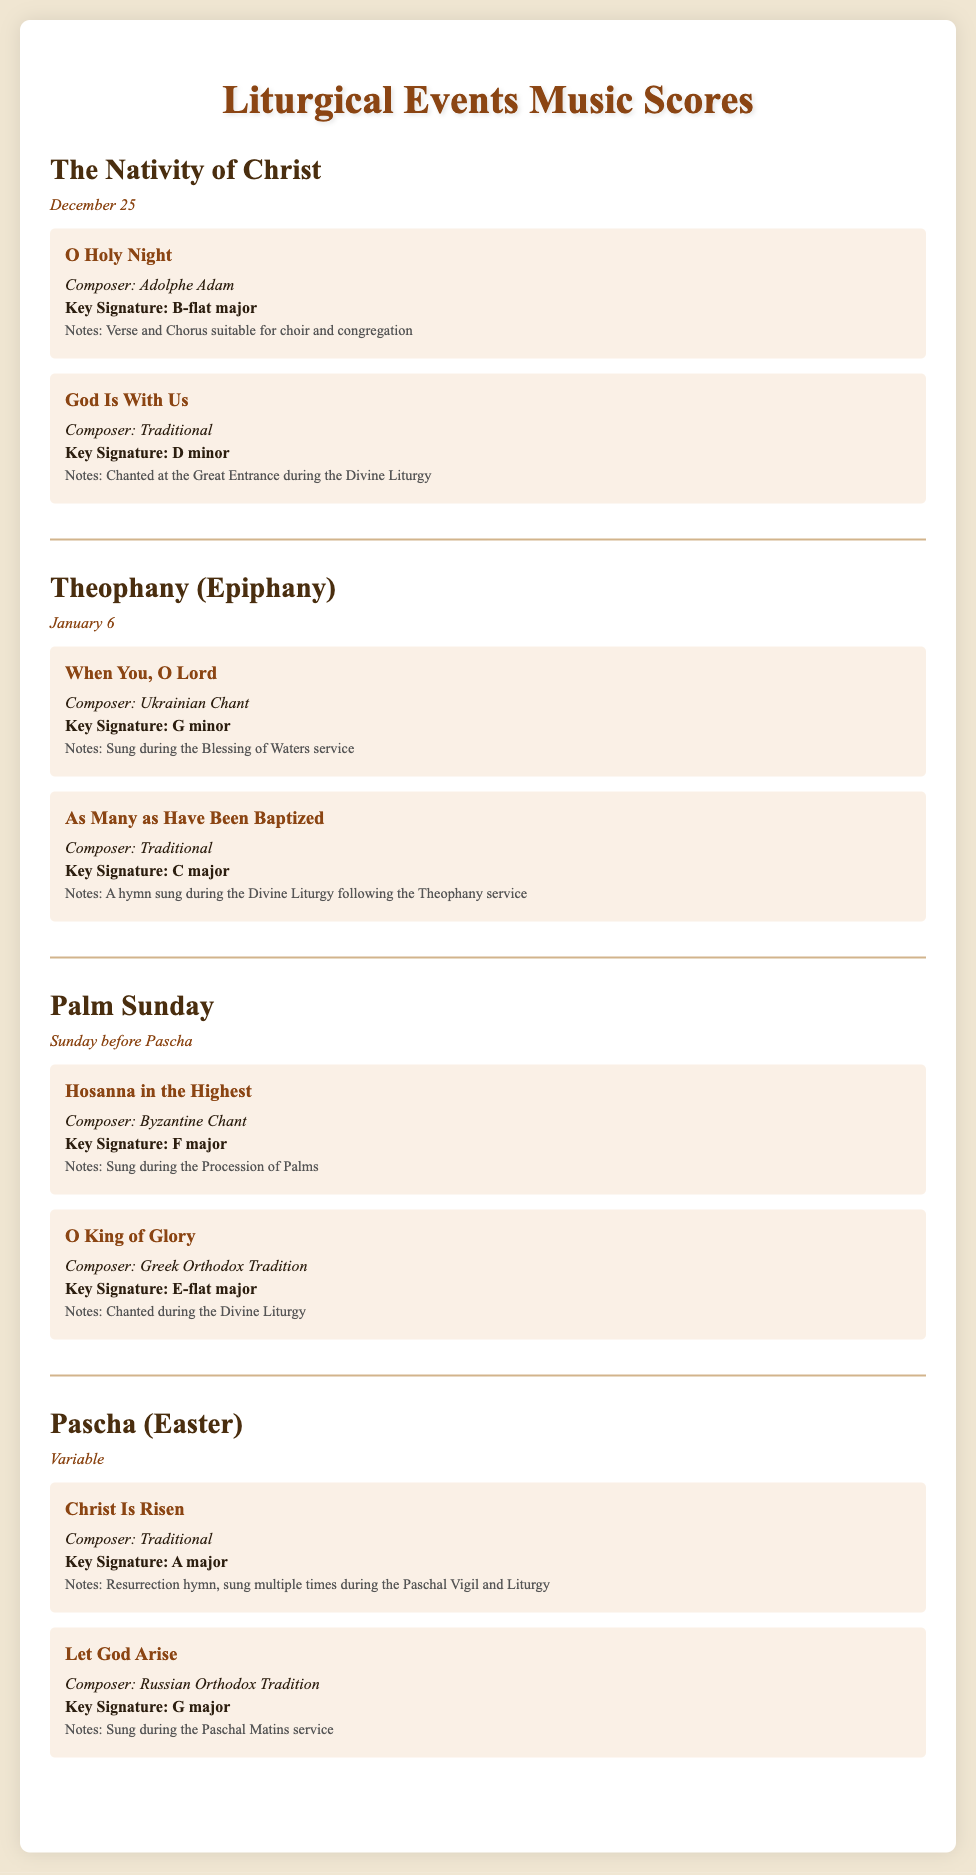What is the date of The Nativity of Christ? The date listed for The Nativity of Christ is December 25.
Answer: December 25 Who composed "When You, O Lord"? The composer of "When You, O Lord" is listed as Ukrainian Chant.
Answer: Ukrainian Chant What is the key signature for "O King of Glory"? The key signature for "O King of Glory" is mentioned as E-flat major.
Answer: E-flat major Which event features "Christ Is Risen"? "Christ Is Risen" is associated with the event Pascha (Easter).
Answer: Pascha (Easter) What type of hymn is "God Is With Us"? "God Is With Us" is described as being chanted at the Great Entrance during the Divine Liturgy.
Answer: Chanted at the Great Entrance What is the key signature for "Let God Arise"? The key signature for "Let God Arise" is stated as G major.
Answer: G major How many scores are listed for the event Palm Sunday? There are two scores provided for the event Palm Sunday.
Answer: Two What is the date for the event Theophany? The date for the event Theophany is January 6.
Answer: January 6 What are the notes for "Let God Arise"? The notes for "Let God Arise" indicate it is sung during the Paschal Matins service.
Answer: Sung during the Paschal Matins service 